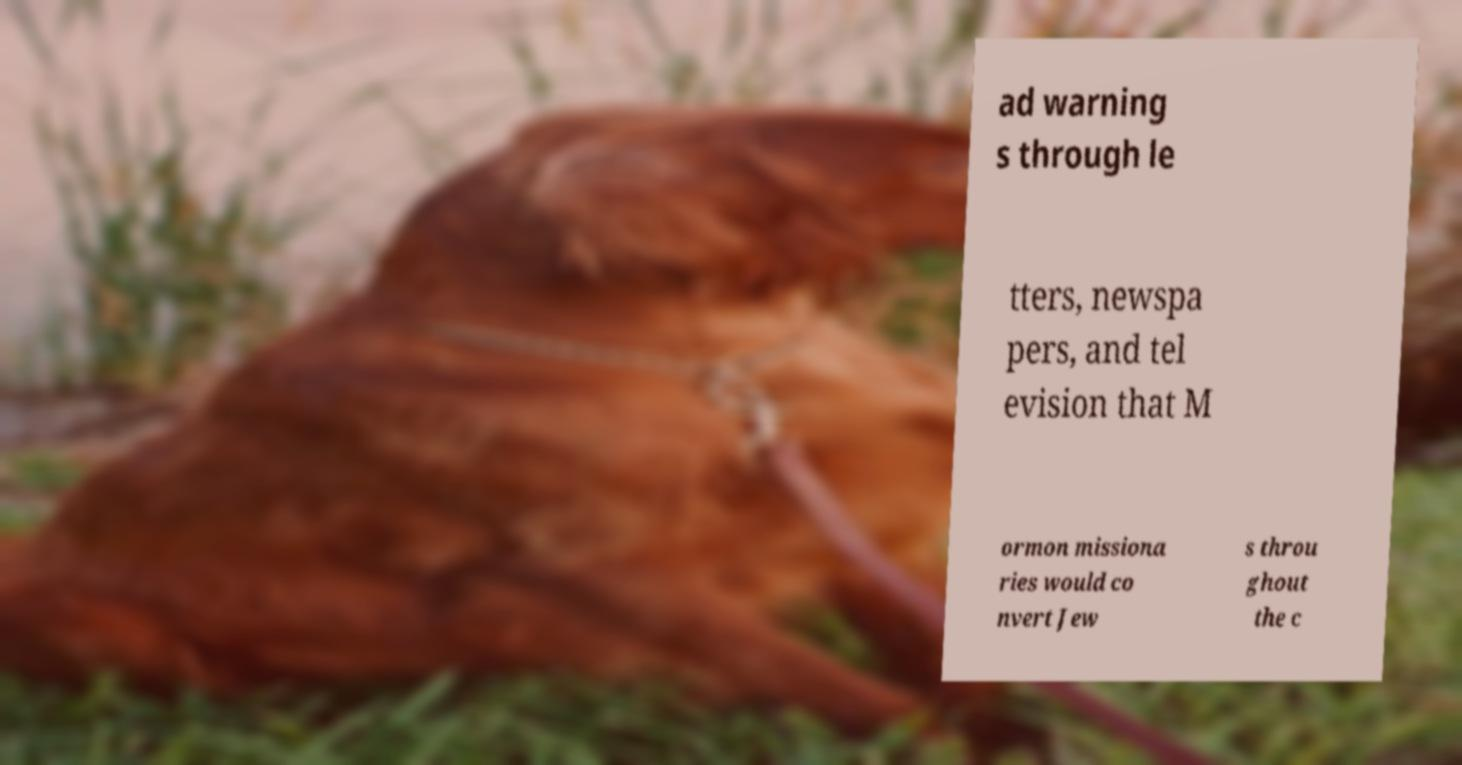For documentation purposes, I need the text within this image transcribed. Could you provide that? ad warning s through le tters, newspa pers, and tel evision that M ormon missiona ries would co nvert Jew s throu ghout the c 